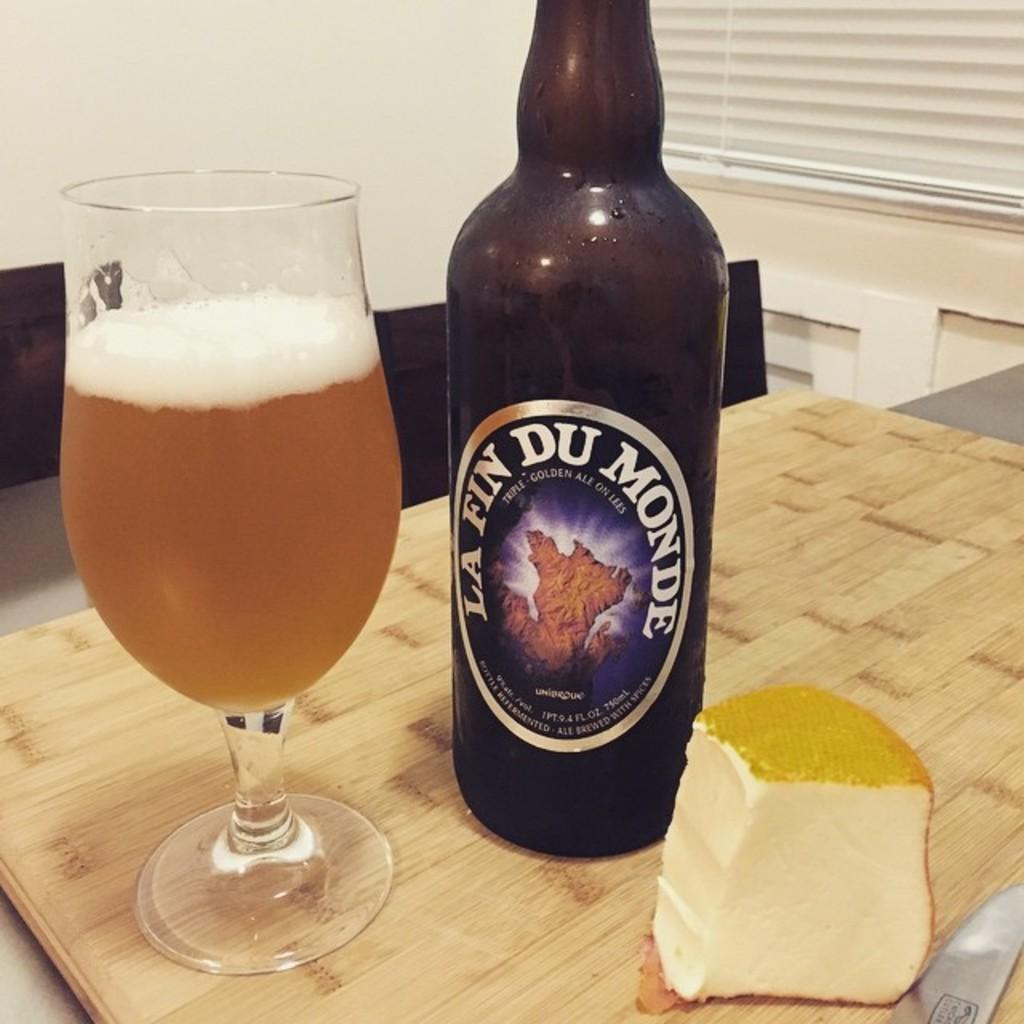<image>
Relay a brief, clear account of the picture shown. A glass filled with La Fin Du Monde ale is next to the bottle and cheese. 